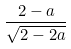Convert formula to latex. <formula><loc_0><loc_0><loc_500><loc_500>\frac { 2 - a } { \sqrt { 2 - 2 a } }</formula> 